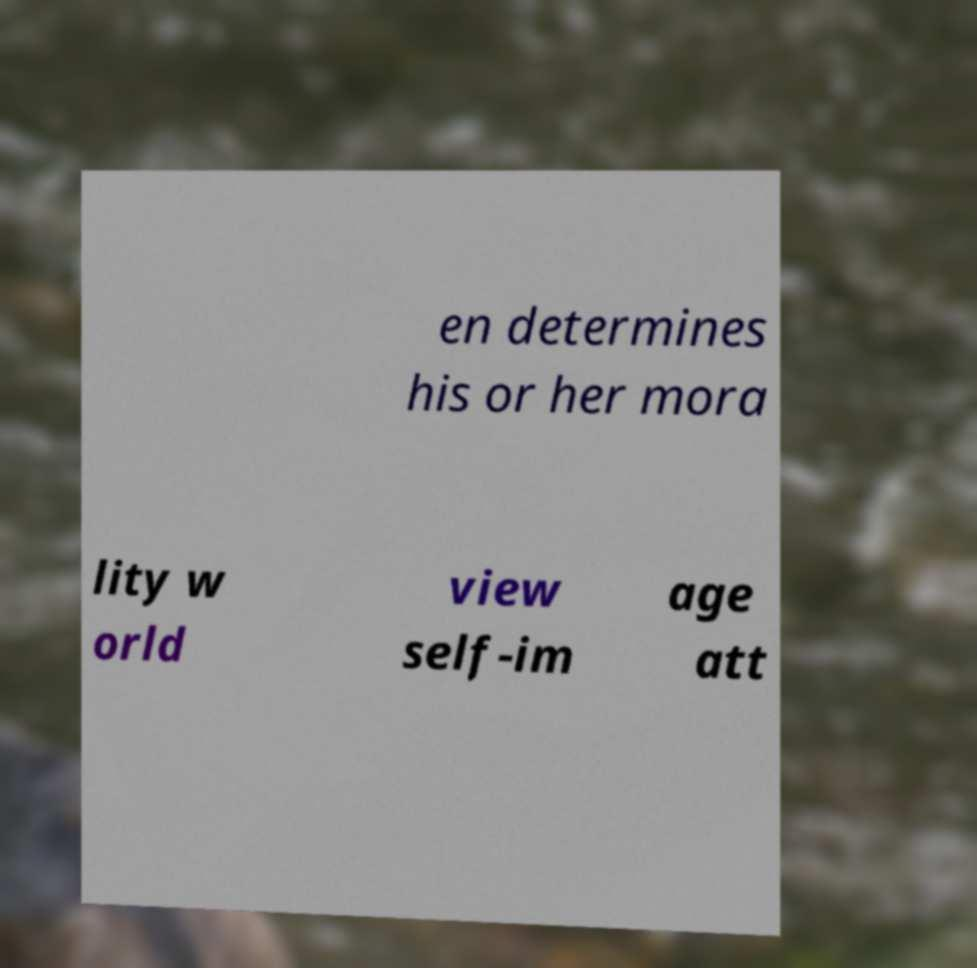Please identify and transcribe the text found in this image. en determines his or her mora lity w orld view self-im age att 